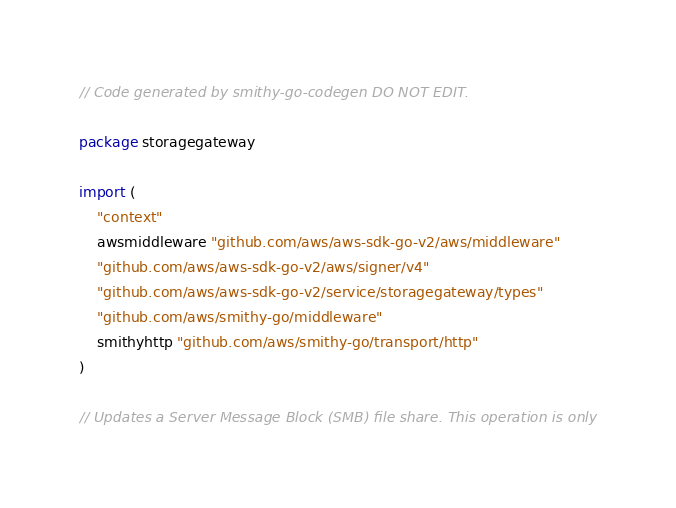<code> <loc_0><loc_0><loc_500><loc_500><_Go_>// Code generated by smithy-go-codegen DO NOT EDIT.

package storagegateway

import (
	"context"
	awsmiddleware "github.com/aws/aws-sdk-go-v2/aws/middleware"
	"github.com/aws/aws-sdk-go-v2/aws/signer/v4"
	"github.com/aws/aws-sdk-go-v2/service/storagegateway/types"
	"github.com/aws/smithy-go/middleware"
	smithyhttp "github.com/aws/smithy-go/transport/http"
)

// Updates a Server Message Block (SMB) file share. This operation is only</code> 